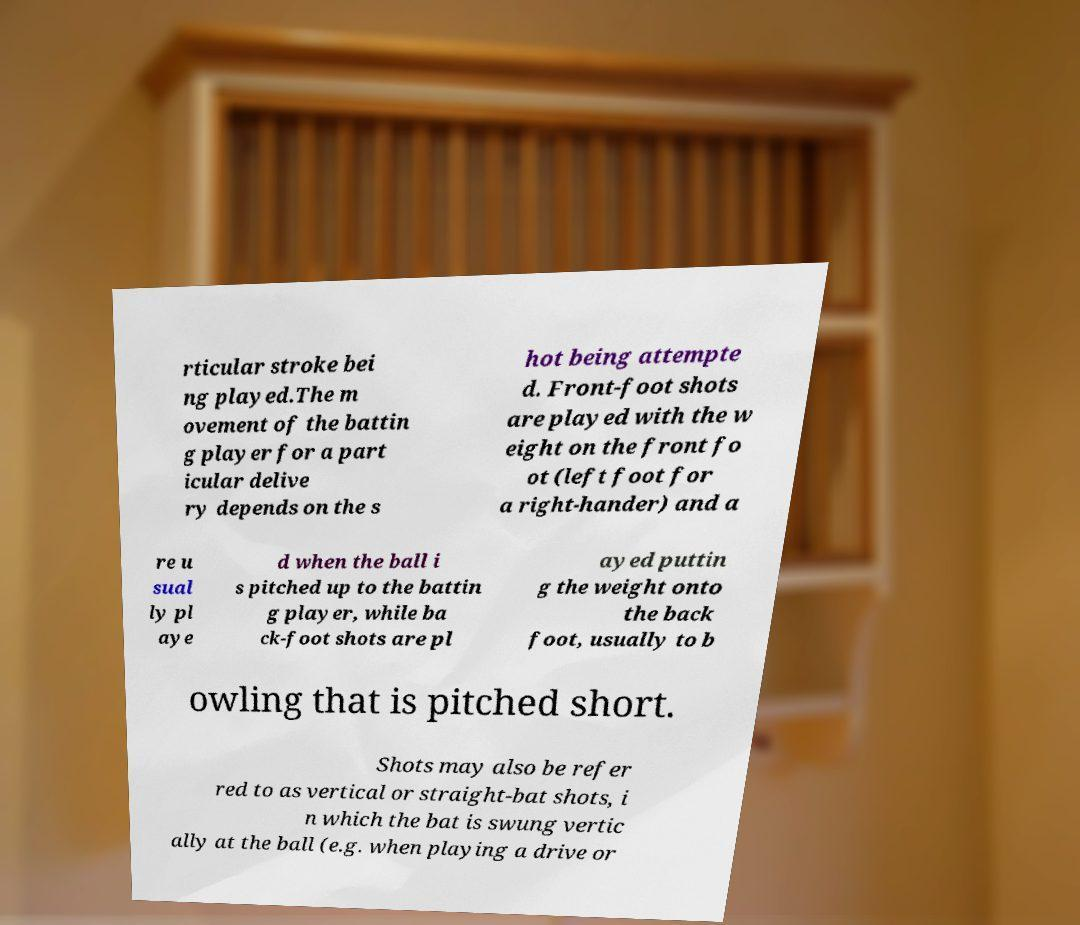Could you extract and type out the text from this image? rticular stroke bei ng played.The m ovement of the battin g player for a part icular delive ry depends on the s hot being attempte d. Front-foot shots are played with the w eight on the front fo ot (left foot for a right-hander) and a re u sual ly pl aye d when the ball i s pitched up to the battin g player, while ba ck-foot shots are pl ayed puttin g the weight onto the back foot, usually to b owling that is pitched short. Shots may also be refer red to as vertical or straight-bat shots, i n which the bat is swung vertic ally at the ball (e.g. when playing a drive or 